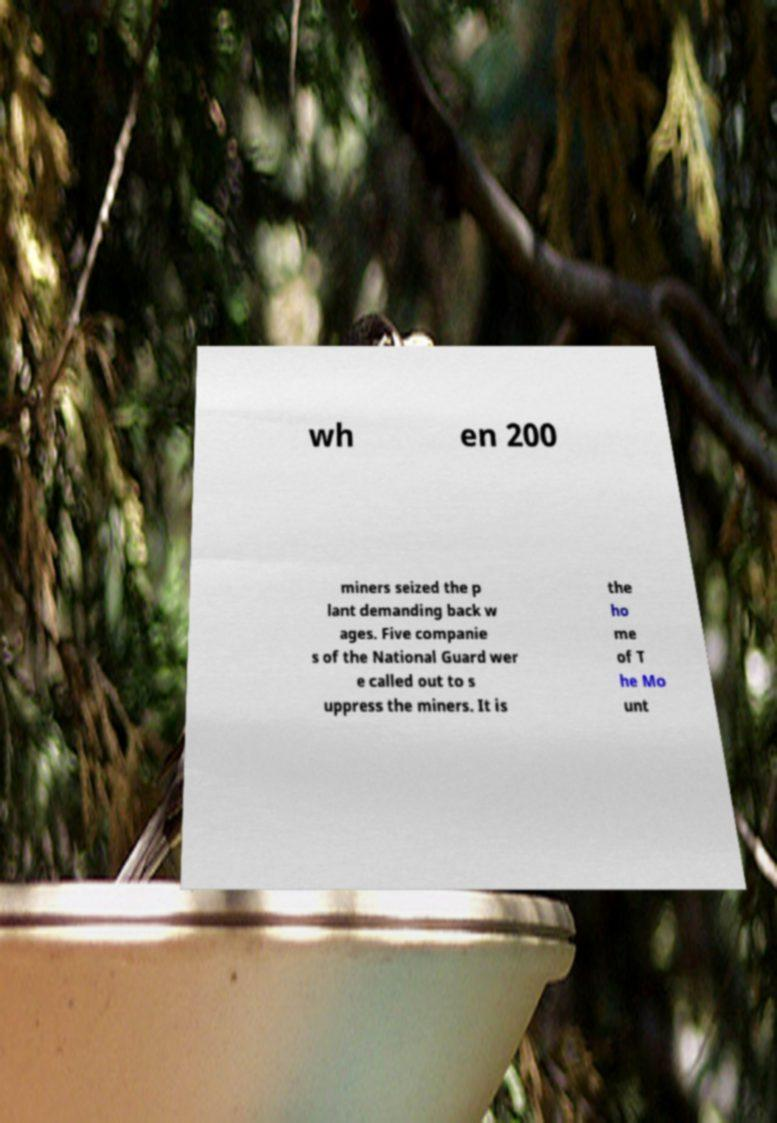For documentation purposes, I need the text within this image transcribed. Could you provide that? wh en 200 miners seized the p lant demanding back w ages. Five companie s of the National Guard wer e called out to s uppress the miners. It is the ho me of T he Mo unt 